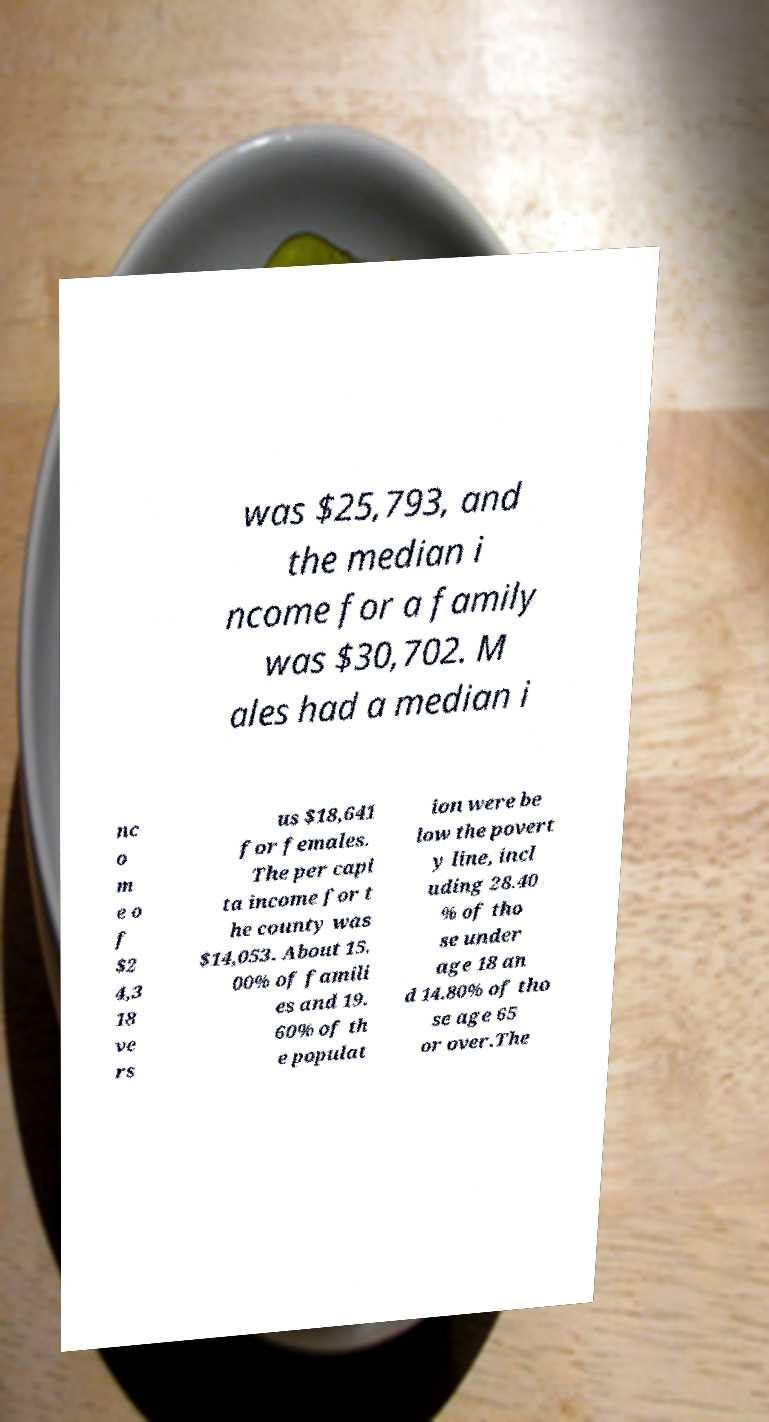For documentation purposes, I need the text within this image transcribed. Could you provide that? was $25,793, and the median i ncome for a family was $30,702. M ales had a median i nc o m e o f $2 4,3 18 ve rs us $18,641 for females. The per capi ta income for t he county was $14,053. About 15. 00% of famili es and 19. 60% of th e populat ion were be low the povert y line, incl uding 28.40 % of tho se under age 18 an d 14.80% of tho se age 65 or over.The 